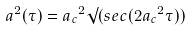Convert formula to latex. <formula><loc_0><loc_0><loc_500><loc_500>a ^ { 2 } ( \tau ) = { a _ { c } } ^ { 2 } \surd ( s e c ( 2 { a _ { c } } ^ { 2 } \tau ) )</formula> 